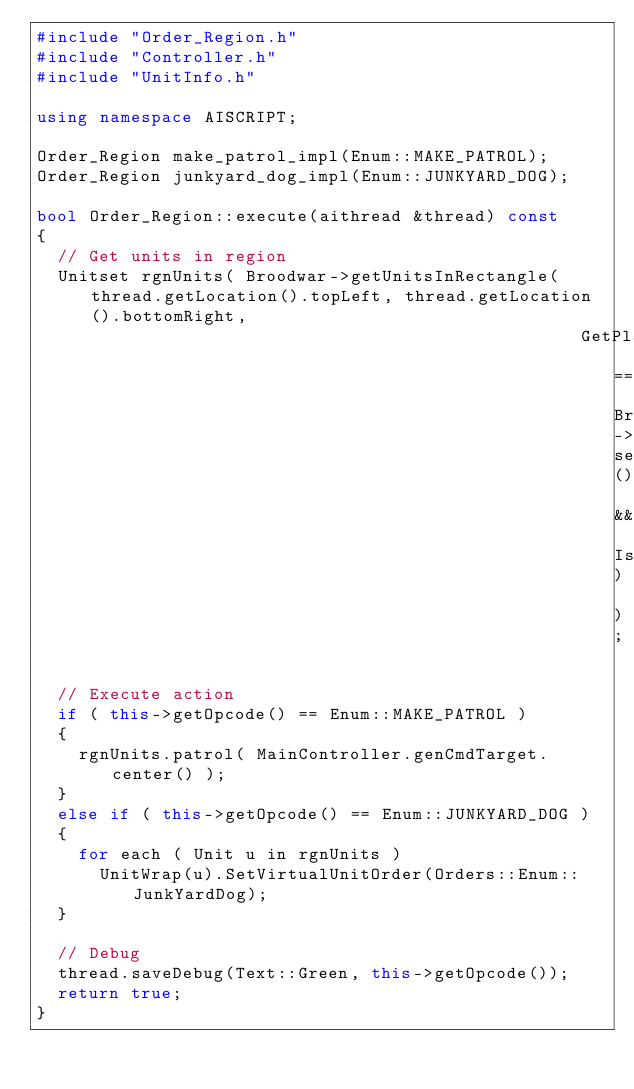Convert code to text. <code><loc_0><loc_0><loc_500><loc_500><_C++_>#include "Order_Region.h"
#include "Controller.h"
#include "UnitInfo.h"

using namespace AISCRIPT;

Order_Region make_patrol_impl(Enum::MAKE_PATROL);
Order_Region junkyard_dog_impl(Enum::JUNKYARD_DOG);

bool Order_Region::execute(aithread &thread) const
{
  // Get units in region
  Unitset rgnUnits( Broodwar->getUnitsInRectangle(thread.getLocation().topLeft, thread.getLocation().bottomRight, 
                                                    GetPlayer == Broodwar->self() && IsCompleted) );
  
  // Execute action
  if ( this->getOpcode() == Enum::MAKE_PATROL )
  {
    rgnUnits.patrol( MainController.genCmdTarget.center() );
  }
  else if ( this->getOpcode() == Enum::JUNKYARD_DOG )
  {
    for each ( Unit u in rgnUnits )
      UnitWrap(u).SetVirtualUnitOrder(Orders::Enum::JunkYardDog);
  }

  // Debug
  thread.saveDebug(Text::Green, this->getOpcode());
  return true;
}
</code> 